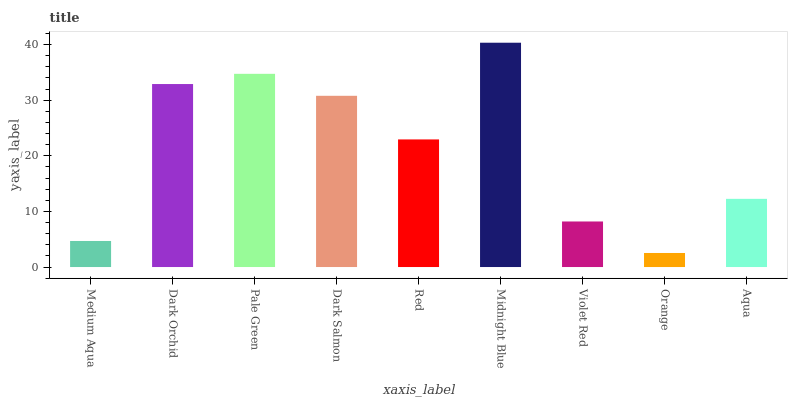Is Orange the minimum?
Answer yes or no. Yes. Is Midnight Blue the maximum?
Answer yes or no. Yes. Is Dark Orchid the minimum?
Answer yes or no. No. Is Dark Orchid the maximum?
Answer yes or no. No. Is Dark Orchid greater than Medium Aqua?
Answer yes or no. Yes. Is Medium Aqua less than Dark Orchid?
Answer yes or no. Yes. Is Medium Aqua greater than Dark Orchid?
Answer yes or no. No. Is Dark Orchid less than Medium Aqua?
Answer yes or no. No. Is Red the high median?
Answer yes or no. Yes. Is Red the low median?
Answer yes or no. Yes. Is Dark Salmon the high median?
Answer yes or no. No. Is Medium Aqua the low median?
Answer yes or no. No. 